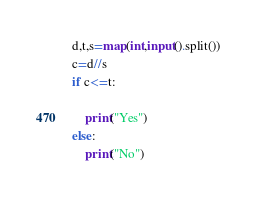<code> <loc_0><loc_0><loc_500><loc_500><_Python_>d,t,s=map(int,input().split())
c=d//s
if c<=t:

    print("Yes")
else:
    print("No")</code> 